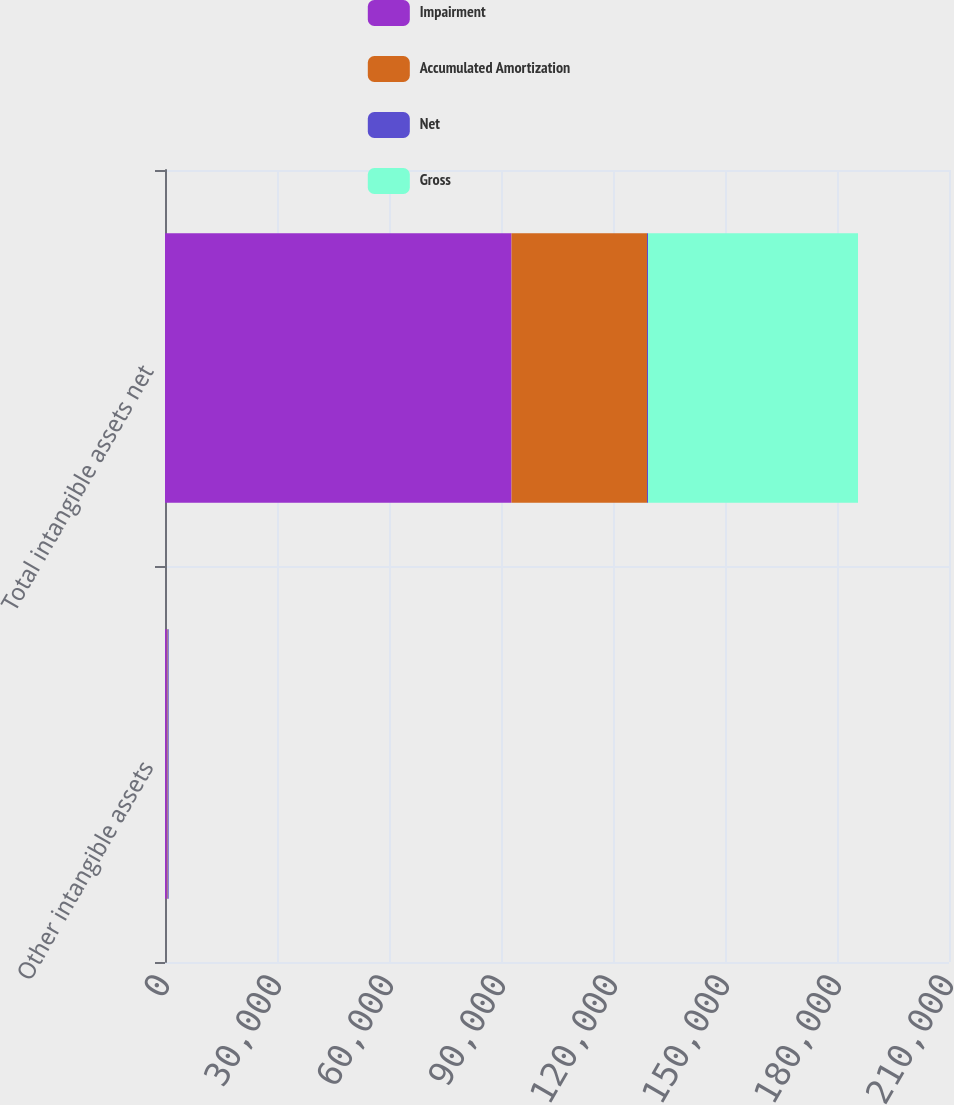Convert chart. <chart><loc_0><loc_0><loc_500><loc_500><stacked_bar_chart><ecel><fcel>Other intangible assets<fcel>Total intangible assets net<nl><fcel>Impairment<fcel>500<fcel>92812<nl><fcel>Accumulated Amortization<fcel>196<fcel>36291<nl><fcel>Net<fcel>291<fcel>291<nl><fcel>Gross<fcel>13<fcel>56230<nl></chart> 